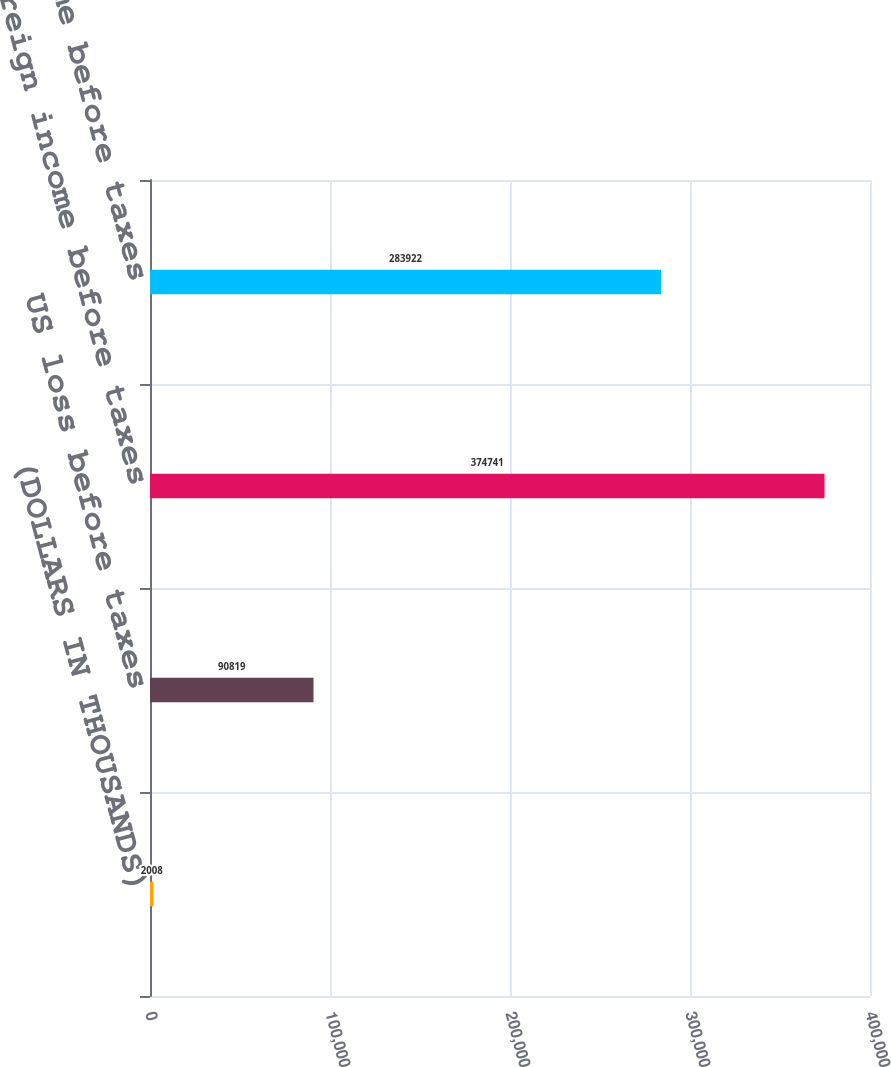Convert chart. <chart><loc_0><loc_0><loc_500><loc_500><bar_chart><fcel>(DOLLARS IN THOUSANDS)<fcel>US loss before taxes<fcel>Foreign income before taxes<fcel>Total income before taxes<nl><fcel>2008<fcel>90819<fcel>374741<fcel>283922<nl></chart> 